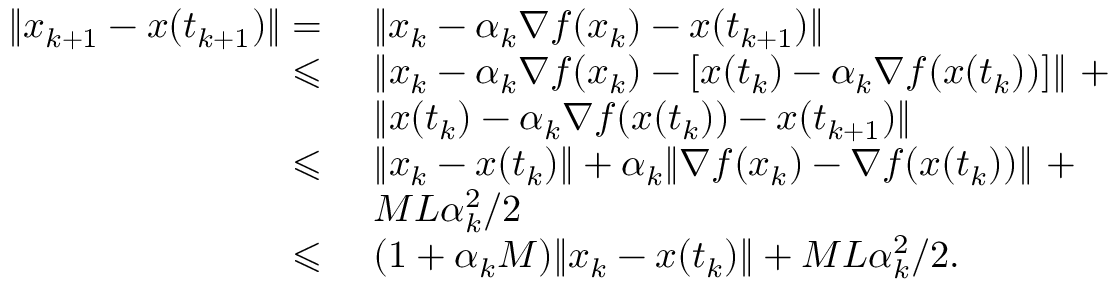<formula> <loc_0><loc_0><loc_500><loc_500>\begin{array} { r l } { \| x _ { k + 1 } - x ( t _ { k + 1 } ) \| = } & { \| x _ { k } - \alpha _ { k } \nabla f ( x _ { k } ) - x ( t _ { k + 1 } ) \| } \\ { \leqslant } & { \| x _ { k } - \alpha _ { k } \nabla f ( x _ { k } ) - [ x ( t _ { k } ) - \alpha _ { k } \nabla f ( x ( t _ { k } ) ) ] \| + } \\ & { \| x ( t _ { k } ) - \alpha _ { k } \nabla f ( x ( t _ { k } ) ) - x ( t _ { k + 1 } ) \| } \\ { \leqslant } & { \| x _ { k } - x ( t _ { k } ) \| + \alpha _ { k } \| \nabla f ( x _ { k } ) - \nabla f ( x ( t _ { k } ) ) \| + } \\ & { M L \alpha _ { k } ^ { 2 } / 2 } \\ { \leqslant } & { ( 1 + \alpha _ { k } M ) \| x _ { k } - x ( t _ { k } ) \| + M L \alpha _ { k } ^ { 2 } / 2 . } \end{array}</formula> 